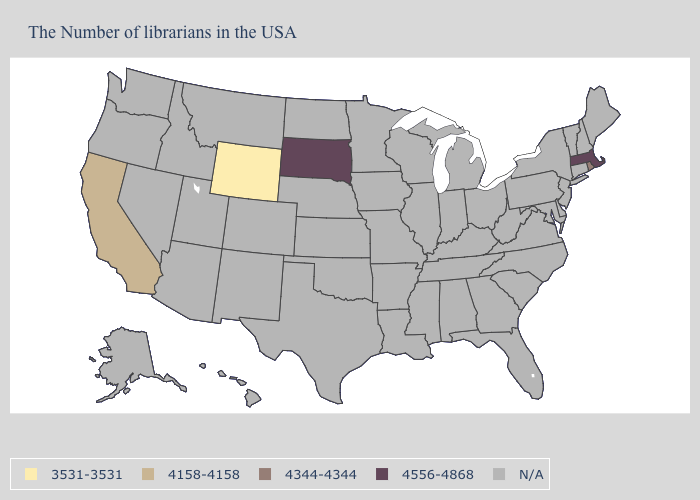What is the value of Florida?
Give a very brief answer. N/A. What is the value of Pennsylvania?
Answer briefly. N/A. Among the states that border Idaho , which have the highest value?
Keep it brief. Wyoming. What is the value of Ohio?
Write a very short answer. N/A. Name the states that have a value in the range 4158-4158?
Short answer required. California. Does the first symbol in the legend represent the smallest category?
Answer briefly. Yes. Does South Dakota have the lowest value in the USA?
Concise answer only. No. What is the lowest value in the USA?
Be succinct. 3531-3531. What is the value of California?
Concise answer only. 4158-4158. What is the value of Utah?
Be succinct. N/A. Does Wyoming have the lowest value in the USA?
Answer briefly. Yes. 